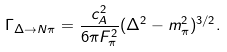<formula> <loc_0><loc_0><loc_500><loc_500>\Gamma _ { \Delta \to N \pi } = \frac { c _ { A } ^ { 2 } } { 6 \pi F _ { \pi } ^ { 2 } } ( \Delta ^ { 2 } - m _ { \pi } ^ { 2 } ) ^ { 3 / 2 } .</formula> 